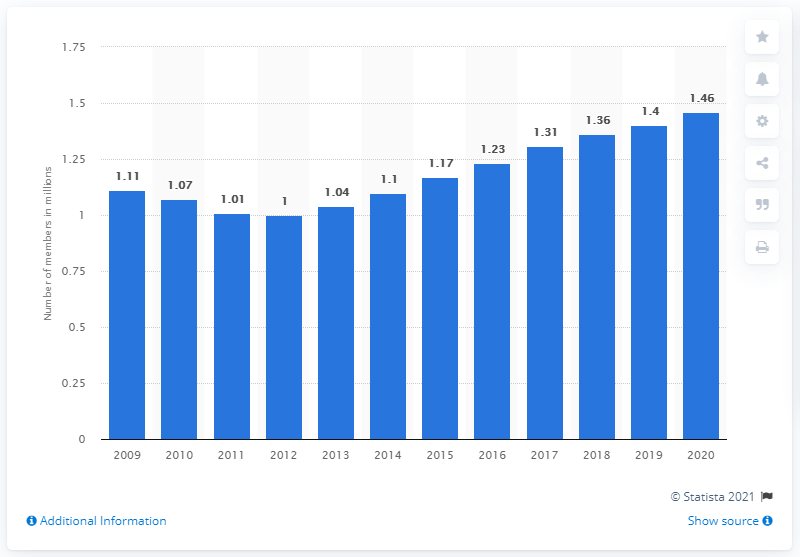Identify some key points in this picture. The membership of the National Association of Realtors in 2020 was 1.46 million. 